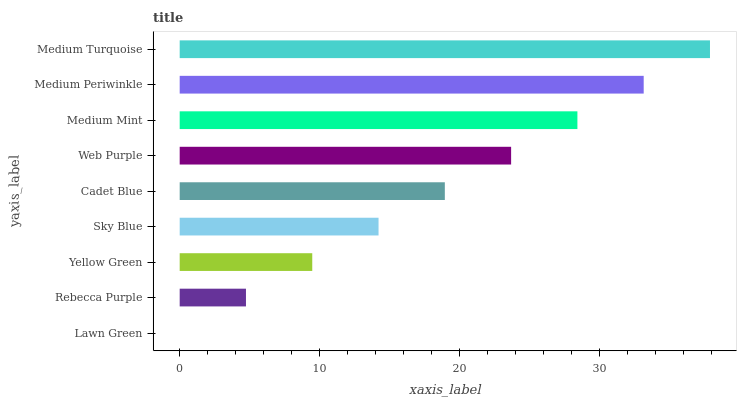Is Lawn Green the minimum?
Answer yes or no. Yes. Is Medium Turquoise the maximum?
Answer yes or no. Yes. Is Rebecca Purple the minimum?
Answer yes or no. No. Is Rebecca Purple the maximum?
Answer yes or no. No. Is Rebecca Purple greater than Lawn Green?
Answer yes or no. Yes. Is Lawn Green less than Rebecca Purple?
Answer yes or no. Yes. Is Lawn Green greater than Rebecca Purple?
Answer yes or no. No. Is Rebecca Purple less than Lawn Green?
Answer yes or no. No. Is Cadet Blue the high median?
Answer yes or no. Yes. Is Cadet Blue the low median?
Answer yes or no. Yes. Is Medium Periwinkle the high median?
Answer yes or no. No. Is Medium Periwinkle the low median?
Answer yes or no. No. 